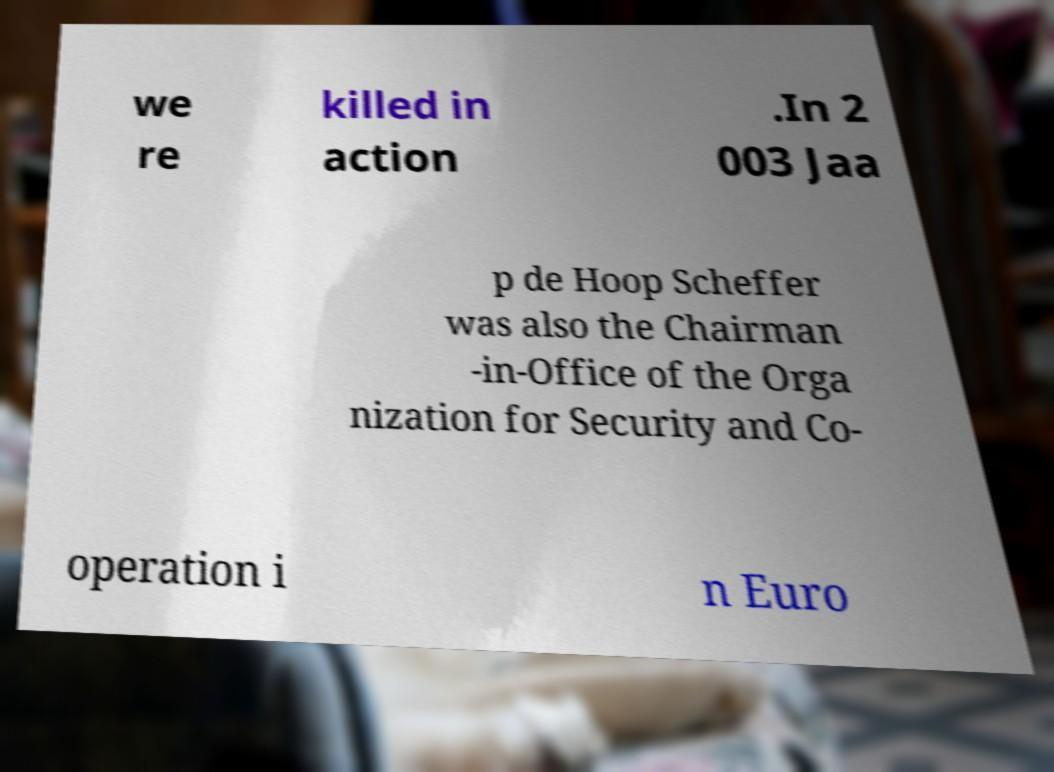Please read and relay the text visible in this image. What does it say? we re killed in action .In 2 003 Jaa p de Hoop Scheffer was also the Chairman -in-Office of the Orga nization for Security and Co- operation i n Euro 